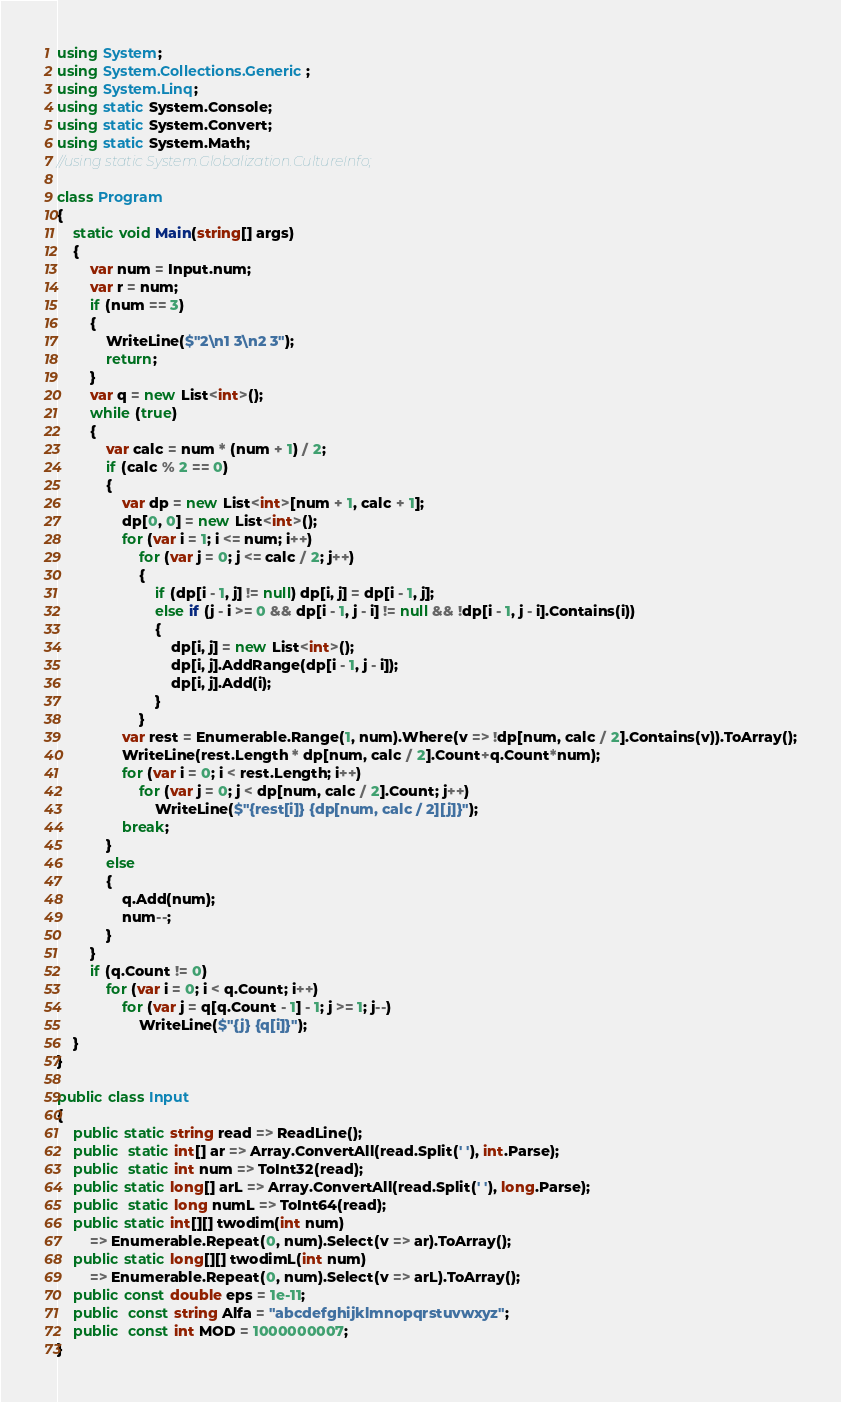Convert code to text. <code><loc_0><loc_0><loc_500><loc_500><_C#_>using System;
using System.Collections.Generic;
using System.Linq;
using static System.Console;
using static System.Convert;
using static System.Math;
//using static System.Globalization.CultureInfo;

class Program
{ 
    static void Main(string[] args)
    {
        var num = Input.num;
        var r = num;
        if (num == 3)
        {
            WriteLine($"2\n1 3\n2 3");
            return;
        }
        var q = new List<int>();
        while (true)
        {
            var calc = num * (num + 1) / 2;
            if (calc % 2 == 0)
            {
                var dp = new List<int>[num + 1, calc + 1];
                dp[0, 0] = new List<int>();
                for (var i = 1; i <= num; i++)
                    for (var j = 0; j <= calc / 2; j++)
                    {
                        if (dp[i - 1, j] != null) dp[i, j] = dp[i - 1, j];
                        else if (j - i >= 0 && dp[i - 1, j - i] != null && !dp[i - 1, j - i].Contains(i))
                        {
                            dp[i, j] = new List<int>();
                            dp[i, j].AddRange(dp[i - 1, j - i]);
                            dp[i, j].Add(i);
                        }
                    }
                var rest = Enumerable.Range(1, num).Where(v => !dp[num, calc / 2].Contains(v)).ToArray();
                WriteLine(rest.Length * dp[num, calc / 2].Count+q.Count*num);
                for (var i = 0; i < rest.Length; i++)
                    for (var j = 0; j < dp[num, calc / 2].Count; j++)
                        WriteLine($"{rest[i]} {dp[num, calc / 2][j]}");
                break;
            }
            else
            {
                q.Add(num);
                num--;
            }
        }
        if (q.Count != 0)
            for (var i = 0; i < q.Count; i++)
                for (var j = q[q.Count - 1] - 1; j >= 1; j--)
                    WriteLine($"{j} {q[i]}");
    }
}

public class Input
{
    public static string read => ReadLine();
    public  static int[] ar => Array.ConvertAll(read.Split(' '), int.Parse);
    public  static int num => ToInt32(read);
    public static long[] arL => Array.ConvertAll(read.Split(' '), long.Parse);
    public  static long numL => ToInt64(read);
    public static int[][] twodim(int num)
        => Enumerable.Repeat(0, num).Select(v => ar).ToArray();
    public static long[][] twodimL(int num)
        => Enumerable.Repeat(0, num).Select(v => arL).ToArray();
    public const double eps = 1e-11;
    public  const string Alfa = "abcdefghijklmnopqrstuvwxyz";
    public  const int MOD = 1000000007;
}
</code> 